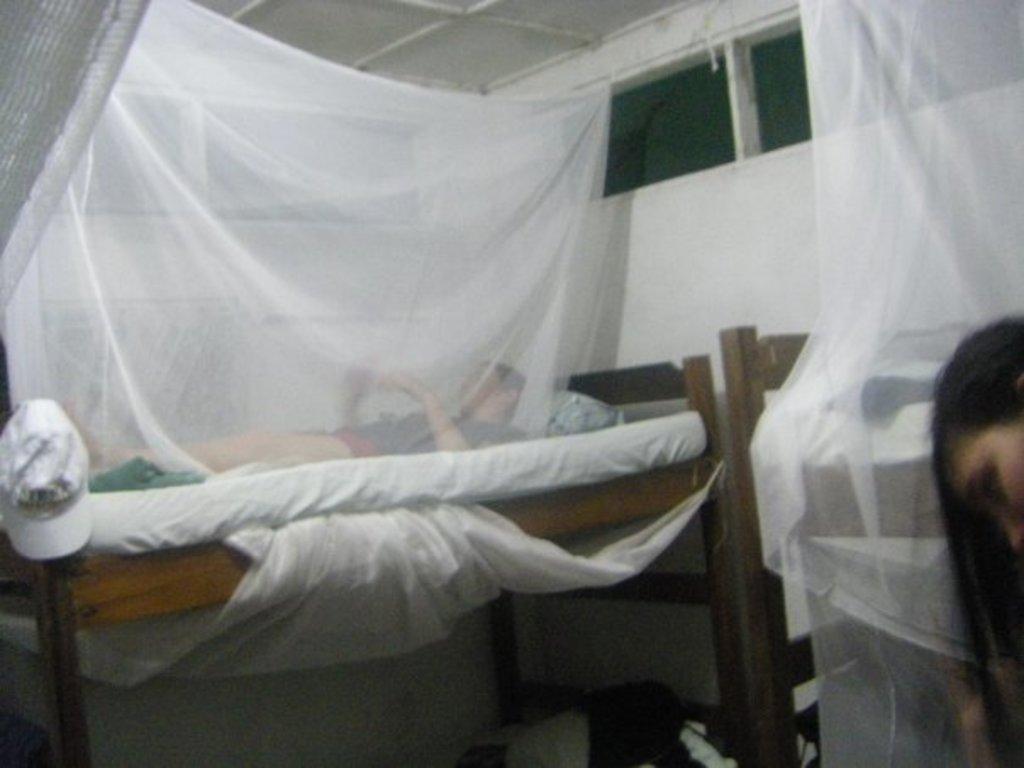How would you summarize this image in a sentence or two? In this image we can a bed on which a man is lying. 